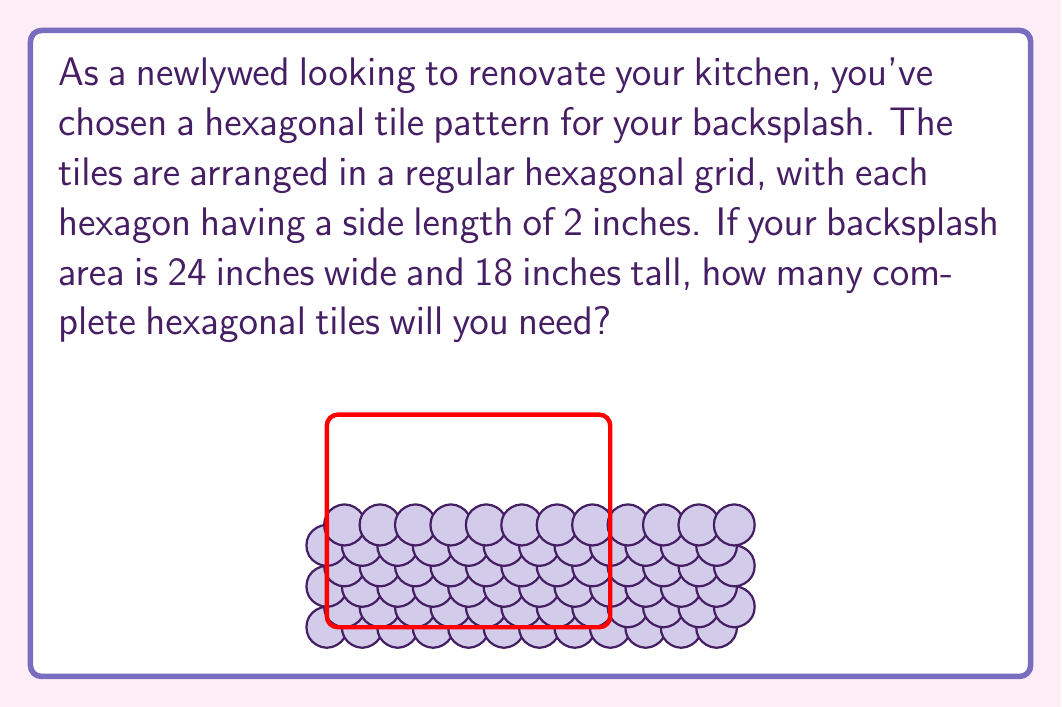Can you answer this question? Let's approach this step-by-step:

1) First, we need to calculate how many tiles fit horizontally and vertically.

2) For the horizontal direction:
   - The width of each tile is $3s/2$, where $s$ is the side length.
   - $s = 2$ inches, so the width of each tile is $3 * 2 / 2 = 3$ inches.
   - The total width is 24 inches.
   - Number of columns = $24 / 3 = 8$ columns

3) For the vertical direction:
   - The height of each tile is $h = s\sqrt{3}$
   - $h = 2\sqrt{3} \approx 3.46$ inches
   - The total height is 18 inches.
   - Number of rows = $18 / 3.46 \approx 5.2$, which rounds down to 5 complete rows.

4) However, due to the hexagonal pattern, every other row is offset and can fit one less tile.

5) So we have:
   - 3 full rows with 8 tiles each: $3 * 8 = 24$
   - 2 offset rows with 7 tiles each: $2 * 7 = 14$

6) Total number of tiles: $24 + 14 = 38$

This calculation ensures you have enough complete tiles to cover the backsplash area without needing to cut any tiles.
Answer: 38 tiles 